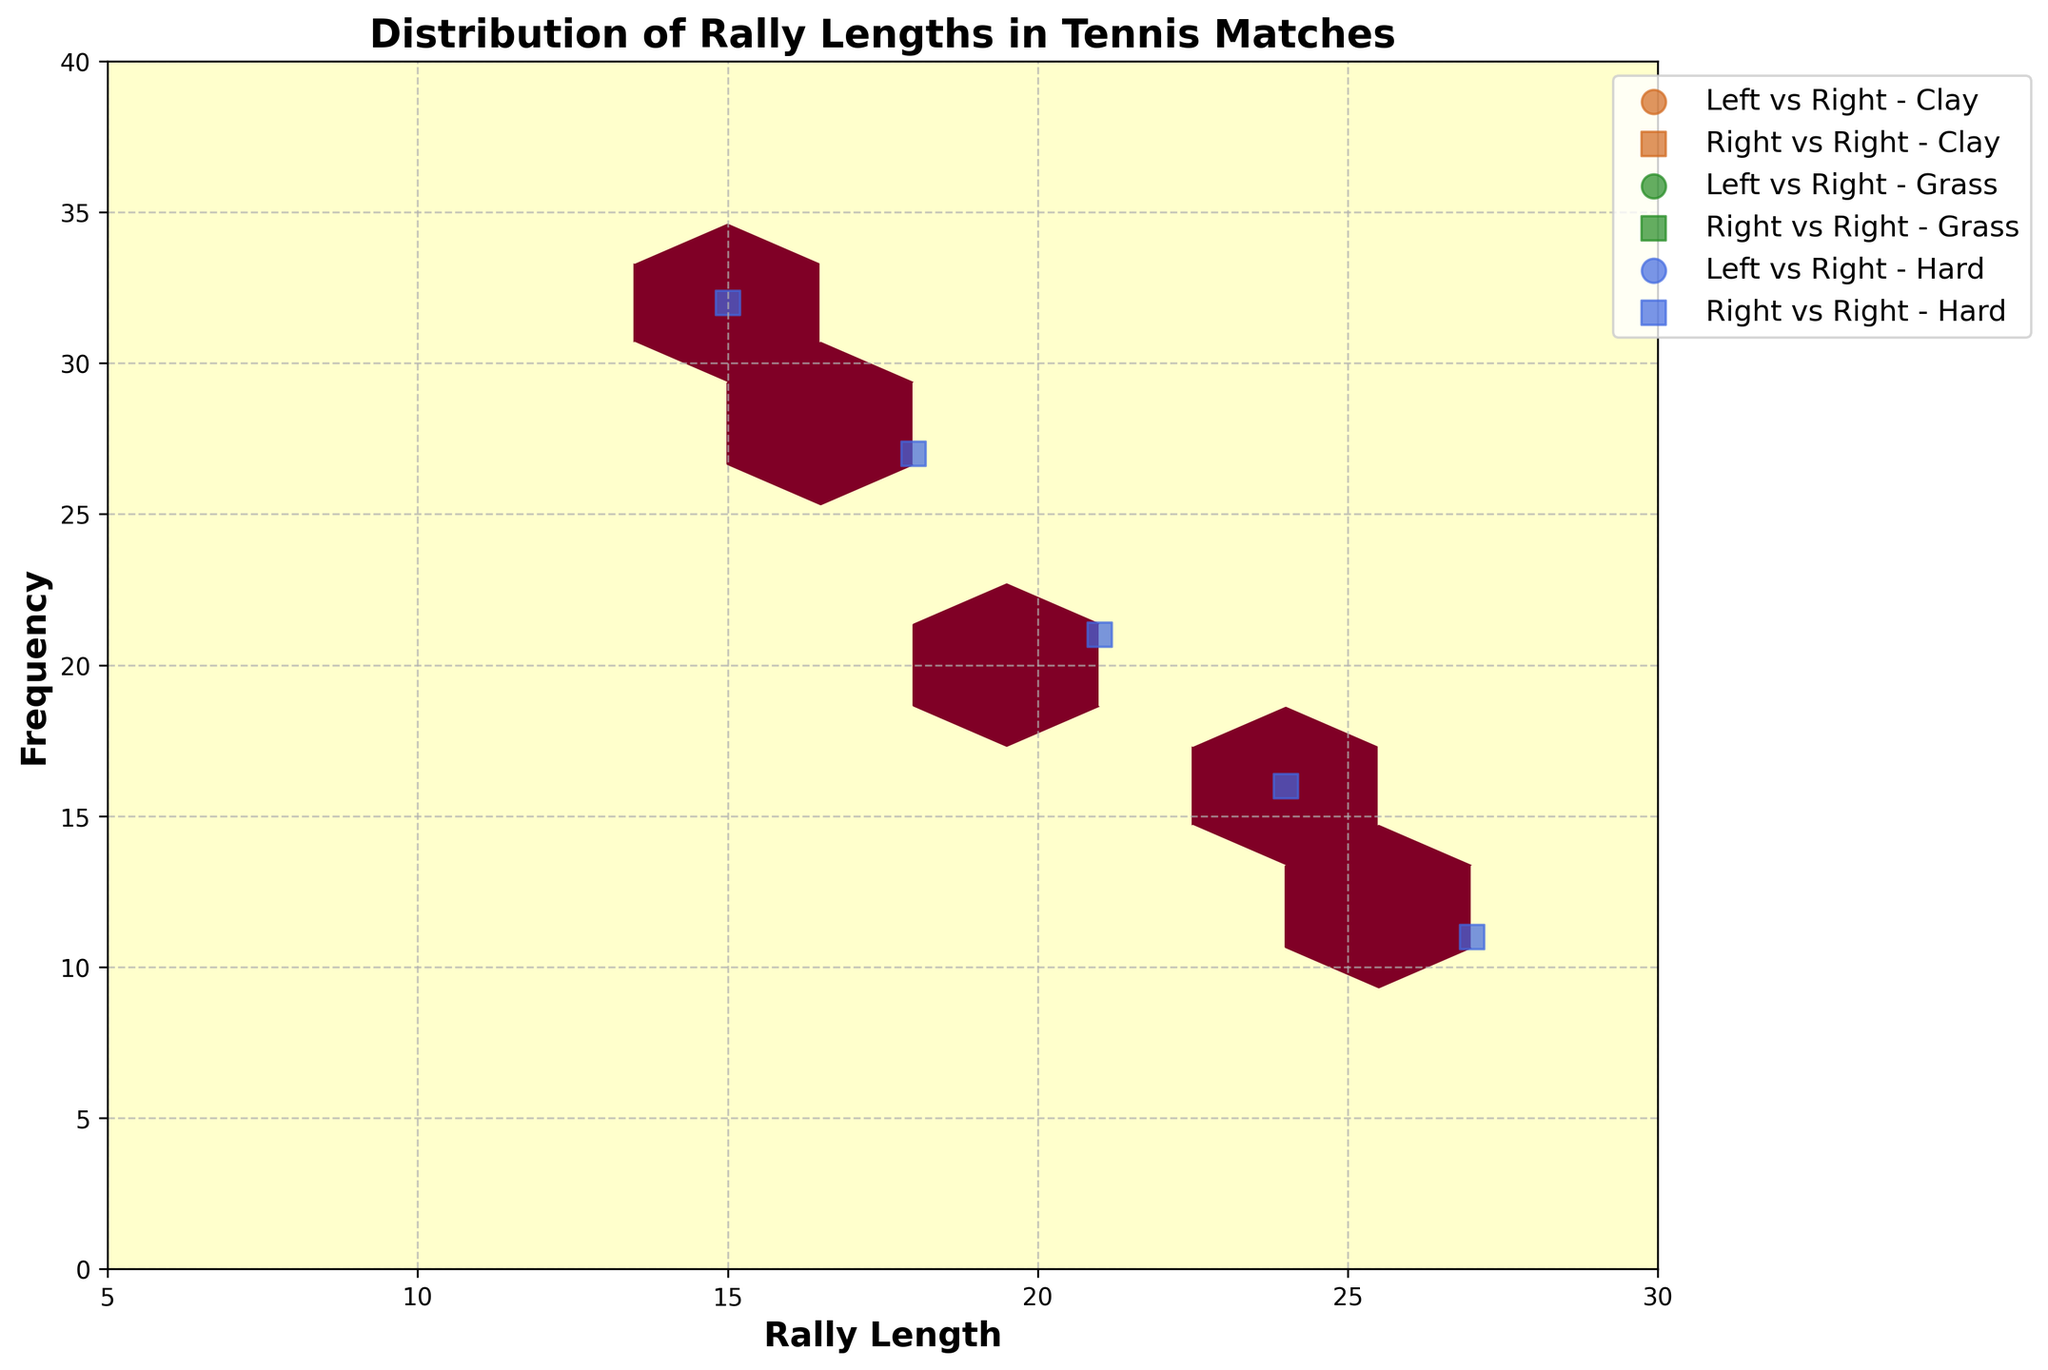How many different court surfaces are represented in the plot? The plot legend lists different court surfaces using distinct colors: Clay, Grass, and Hard. By counting these surfaces, we determine that there are three surfaces represented.
Answer: Three What is the title of the plot? The title is displayed at the top center of the plot. It reads "Distribution of Rally Lengths in Tennis Matches."
Answer: Distribution of Rally Lengths in Tennis Matches Which court surface shows the highest frequency for rally lengths between 12 and 15 in matches involving Right-handed vs. Right-handed players? By examining the data points for Grass, Clay, and Hard surfaces in matches involving Right vs. Right players, we can see that the Grass surface has the highest recorded frequencies for rally lengths within that range.
Answer: Grass Do Left vs. Right and Right vs. Right matches on Clay courts have similar patterns for rally lengths of 15? By comparing the data points and hexbin areas for rally lengths of 15 for both match types on Clay courts, we can see that they both show high frequencies, indicating a similar pattern.
Answer: Yes Between Clay and Grass surfaces, which one generally shows a higher frequency for shorter rally lengths? By looking at the data points for rally lengths below 15, Grass surface points are generally located higher on the frequency axis compared to Clay surface points.
Answer: Grass What is the frequency of the longest rally length recorded on Hard courts in matches involving Left-handed vs. Right-handed players? For Left vs. Right matches on Hard courts, the longest rally length data point is at 27, and its frequency can be identified near the plotted point.
Answer: 9 Which corresponds to higher frequency: a rally length of 21 on Hard courts or on Clay courts for Right vs. Right matches? By comparing the data points for a rally length of 21 on both Hard and Clay surfaces for Right vs. Right matches, the one on Hard court shows a significantly higher frequency.
Answer: Hard courts What visual marker shape represents matches between Left-handed and Right-handed players? The plot uses different marker shapes to differentiate between match types, and circles represent matches between Left-handed and Right-handed players.
Answer: Circles Which court surface, based on the color-coding in the plot, represents the high-frequency rally lengths for Right vs. Right matches? By checking the color representations in the plot, Clay and Grass surfaces appear to have high-frequency rally lengths for Right vs. Right matches, particularly in the shorter rally lengths range.
Answer: Clay and Grass In matches between Right vs. Right players on Grass courts, what rally length has the highest frequency? Examining the data points for Right vs. Right matches on Grass courts, the rally length of 9 has the highest frequency as indicated by the position of the highest data point.
Answer: 9 